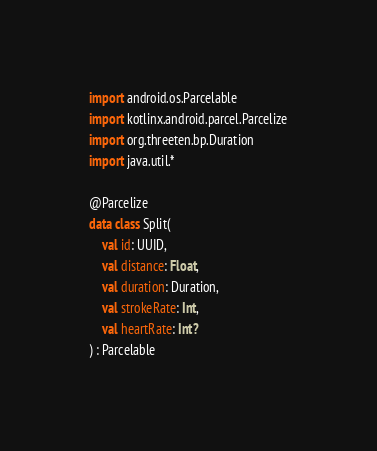<code> <loc_0><loc_0><loc_500><loc_500><_Kotlin_>
import android.os.Parcelable
import kotlinx.android.parcel.Parcelize
import org.threeten.bp.Duration
import java.util.*

@Parcelize
data class Split(
    val id: UUID,
    val distance: Float,
    val duration: Duration,
    val strokeRate: Int,
    val heartRate: Int?
) : Parcelable</code> 